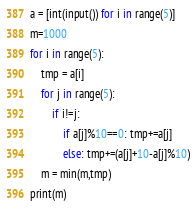<code> <loc_0><loc_0><loc_500><loc_500><_Python_>a = [int(input()) for i in range(5)]
m=1000
for i in range(5):
    tmp = a[i]
    for j in range(5):
        if i!=j:
            if a[j]%10==0: tmp+=a[j]
            else: tmp+=(a[j]+10-a[j]%10)
    m = min(m,tmp)
print(m)</code> 